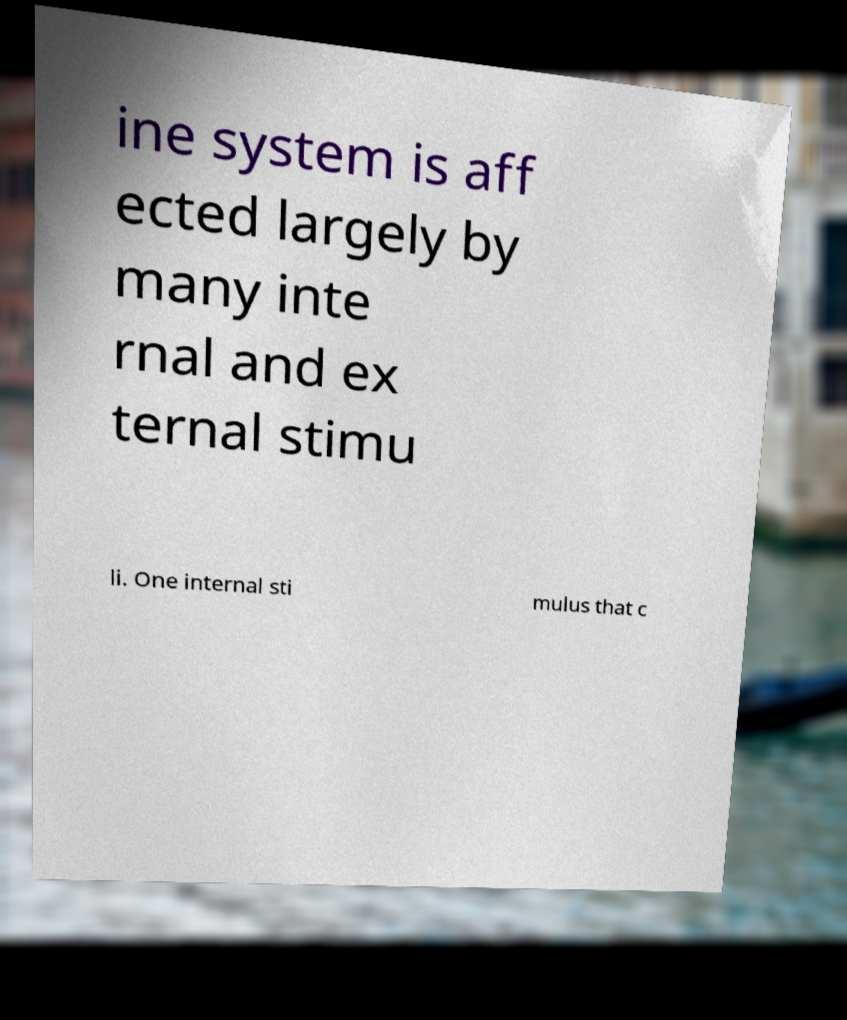Could you assist in decoding the text presented in this image and type it out clearly? ine system is aff ected largely by many inte rnal and ex ternal stimu li. One internal sti mulus that c 